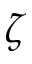Convert formula to latex. <formula><loc_0><loc_0><loc_500><loc_500>\zeta</formula> 